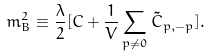Convert formula to latex. <formula><loc_0><loc_0><loc_500><loc_500>m _ { B } ^ { 2 } \equiv \frac { \lambda } { 2 } [ C + \frac { 1 } { V } \sum _ { p \neq 0 } \tilde { C } _ { p , - p } ] .</formula> 